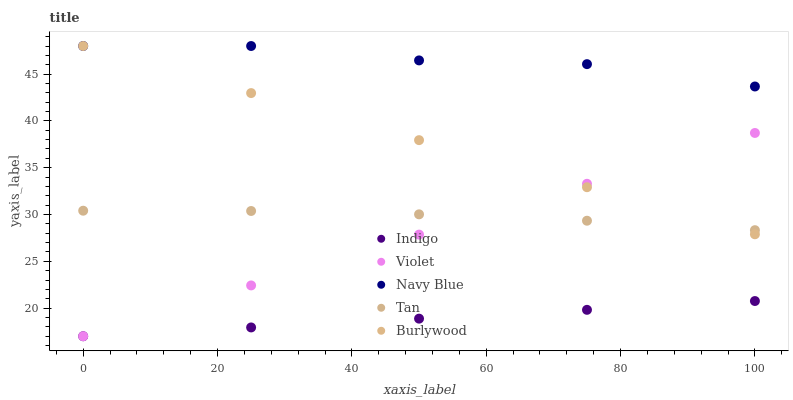Does Indigo have the minimum area under the curve?
Answer yes or no. Yes. Does Navy Blue have the maximum area under the curve?
Answer yes or no. Yes. Does Tan have the minimum area under the curve?
Answer yes or no. No. Does Tan have the maximum area under the curve?
Answer yes or no. No. Is Indigo the smoothest?
Answer yes or no. Yes. Is Navy Blue the roughest?
Answer yes or no. Yes. Is Tan the smoothest?
Answer yes or no. No. Is Tan the roughest?
Answer yes or no. No. Does Indigo have the lowest value?
Answer yes or no. Yes. Does Tan have the lowest value?
Answer yes or no. No. Does Navy Blue have the highest value?
Answer yes or no. Yes. Does Tan have the highest value?
Answer yes or no. No. Is Violet less than Navy Blue?
Answer yes or no. Yes. Is Burlywood greater than Indigo?
Answer yes or no. Yes. Does Burlywood intersect Violet?
Answer yes or no. Yes. Is Burlywood less than Violet?
Answer yes or no. No. Is Burlywood greater than Violet?
Answer yes or no. No. Does Violet intersect Navy Blue?
Answer yes or no. No. 